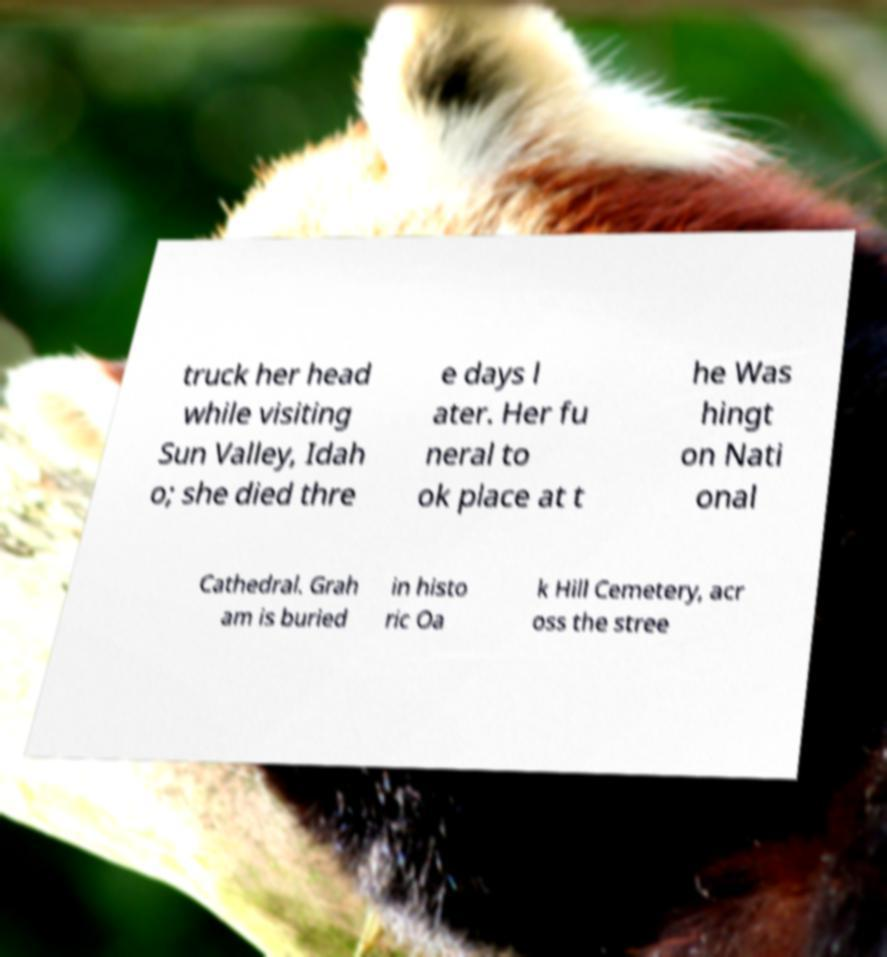Can you read and provide the text displayed in the image?This photo seems to have some interesting text. Can you extract and type it out for me? truck her head while visiting Sun Valley, Idah o; she died thre e days l ater. Her fu neral to ok place at t he Was hingt on Nati onal Cathedral. Grah am is buried in histo ric Oa k Hill Cemetery, acr oss the stree 